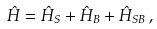Convert formula to latex. <formula><loc_0><loc_0><loc_500><loc_500>\hat { H } = \hat { H } _ { S } + \hat { H } _ { B } + \hat { H } _ { S B } \, ,</formula> 